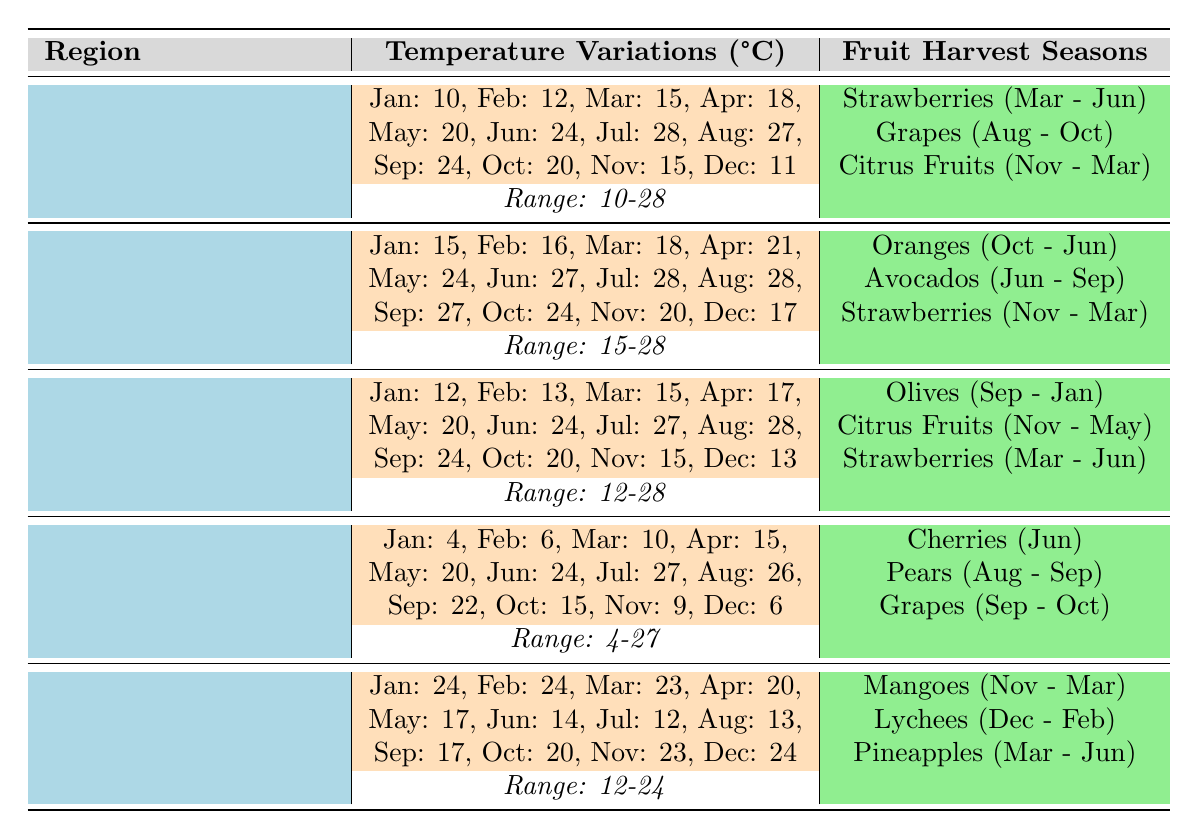What is the temperature range in California? From the temperature variations data for California, the lowest temperature is 10°C in January and the highest is 28°C in July. Therefore, the range is 28°C - 10°C = 18°C.
Answer: 18°C Which fruit is harvested in Italy in June? According to the fruit harvest seasons for Italy, cherries are harvested in June.
Answer: Cherries Do Florida's temperatures exceed 20°C in the summer months? The summer months in Florida are June, July, and August. Looking at the temperature variations, June is 27°C, July is 28°C, and August is 28°C. Since all these temperatures are greater than 20°C, the answer is yes.
Answer: Yes What is the average temperature in Spain during the months of March to May? For Spain, the temperatures for March, April, and May are 15°C, 17°C, and 20°C, respectively. To find the average, sum the temperatures: 15 + 17 + 20 = 52, then divide by 3: 52 / 3 ≈ 17.33°C.
Answer: 17.33°C Is it true that strawberries are harvested in December in California? California's fruit harvest seasons indicate that strawberries are harvested from March to June, which means they are not harvested in December.
Answer: No 